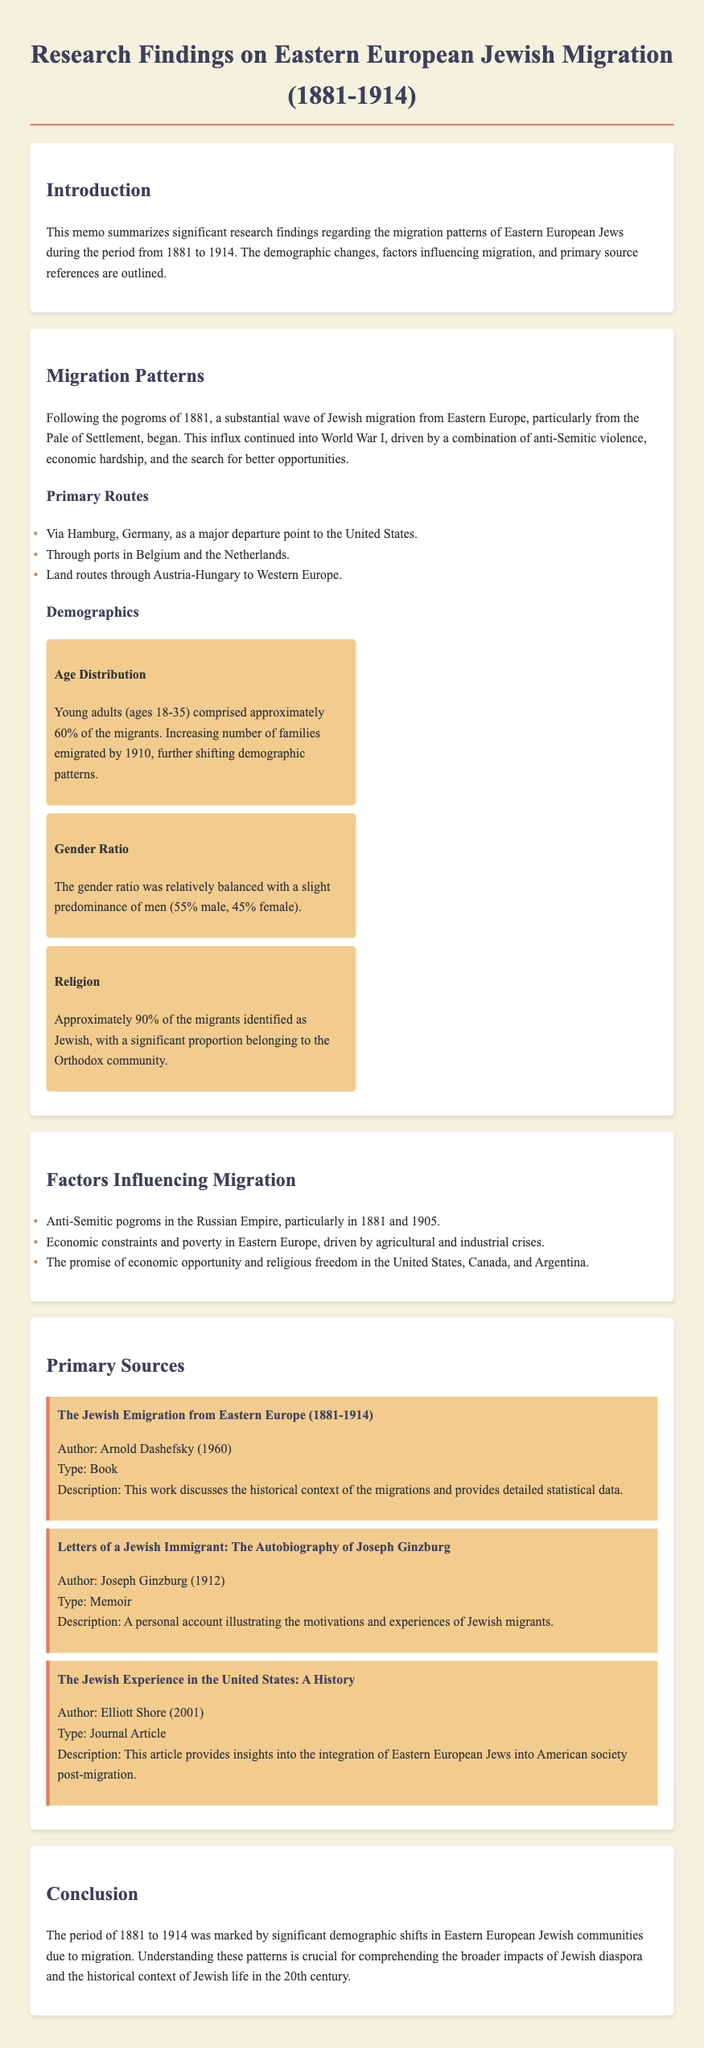What event triggered the mass migration in 1881? The memo mentions that significant Jewish migration began following the pogroms of 1881.
Answer: pogroms What percentage of the migrants were young adults between 18 and 35 years old? The document states that young adults (ages 18-35) comprised approximately 60% of the migrants.
Answer: 60% What was the gender ratio of the migrants? The document indicates that the gender ratio was 55% male and 45% female.
Answer: 55% male, 45% female Which major departure point is identified for migrants heading to the United States? The memo specifies Hamburg, Germany, as a major departure point.
Answer: Hamburg, Germany Name one significant factor influencing migration highlighted in the document. The memo lists several factors influencing migration, one of which is anti-Semitic pogroms.
Answer: anti-Semitic pogroms What is the title of the book written by Arnold Dashefsky? The document provides the title of the book authored by Arnold Dashefsky as "The Jewish Emigration from Eastern Europe (1881-1914)."
Answer: The Jewish Emigration from Eastern Europe (1881-1914) What year did Joseph Ginzburg publish his memoir? The document states that Joseph Ginzburg published his memoir in 1912.
Answer: 1912 Who authored the journal article titled "The Jewish Experience in the United States: A History"? The memo mentions Elliott Shore as the author of this journal article.
Answer: Elliott Shore 